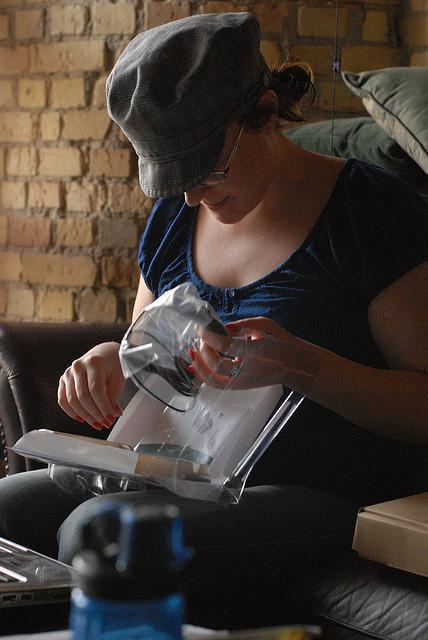What's the lady wearing on her head?
Indicate the correct response by choosing from the four available options to answer the question.
Options: Hijab, glasses, nothing, cap. Cap. 